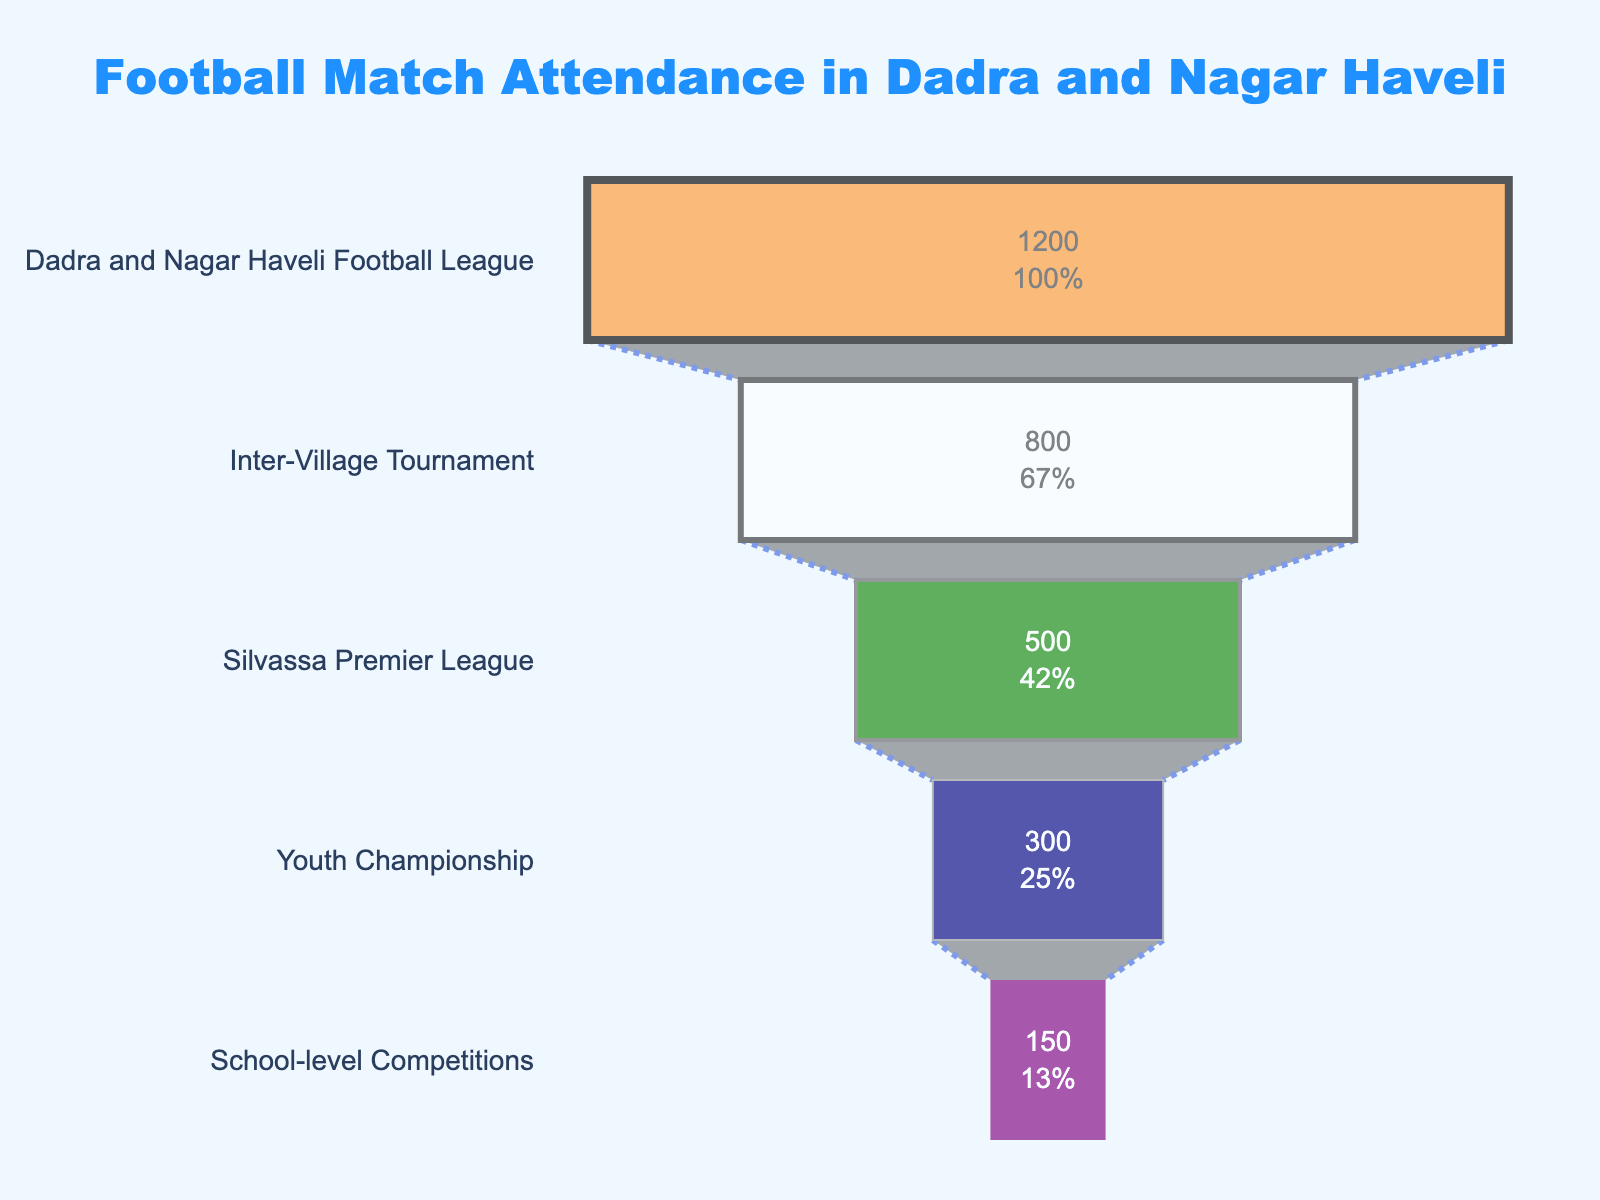What's the title of the chart? The title is displayed at the top center of the chart.
Answer: Football Match Attendance in Dadra and Nagar Haveli How many league levels are shown in the figure? Each league level is represented as a segment in the funnel chart.
Answer: 5 What are the colors used to represent the different league levels? Each league level is shown with a different color, starting from the top: orange, white, green, navy blue, purple.
Answer: Orange, white, green, navy blue, purple Which league has the highest average attendance? The funnel chart shows the widest segment at the top, which represents the league with the highest attendance.
Answer: Dadra and Nagar Haveli Football League How much larger is the average attendance for the Inter-Village Tournament compared to School-level Competitions? Subtract the average attendance of School-level Competitions from the Inter-Village Tournament. (800 - 150)
Answer: 650 What percentage of the initial attendance is accounted for by the Youth Championship? The Youth Championship segment shows the attendance value and the percentage of the total in the figure. It’s 300 attendees out of the starting 1200 from the top league. (300/1200)*100
Answer: 25% What is the combined average attendance of the Silvassa Premier League and the Youth Championship? Add the average attendance of both leagues: 500 (Silvassa Premier League) + 300 (Youth Championship)
Answer: 800 Which league has a higher average attendance: Silvassa Premier League or Inter-Village Tournament? Compare the attendance values of the two leagues. Silvassa has 500 and Inter-Village has 800.
Answer: Inter-Village Tournament Is the attendance for School-level Competitions less than half of that for Dadra and Nagar Haveli Football League? Check if the attendance of School-level Competitions (150) is less than half of the Dadra and Nagar Haveli Football League (600). (150 < 1200/2)
Answer: Yes What is the average attendance difference between the league level with the highest attendance and the league level with the lowest attendance? Subtract the attendance for School-level Competitions (150) from Dadra and Nagar Haveli Football League (1200). (1200 - 150)
Answer: 1050 